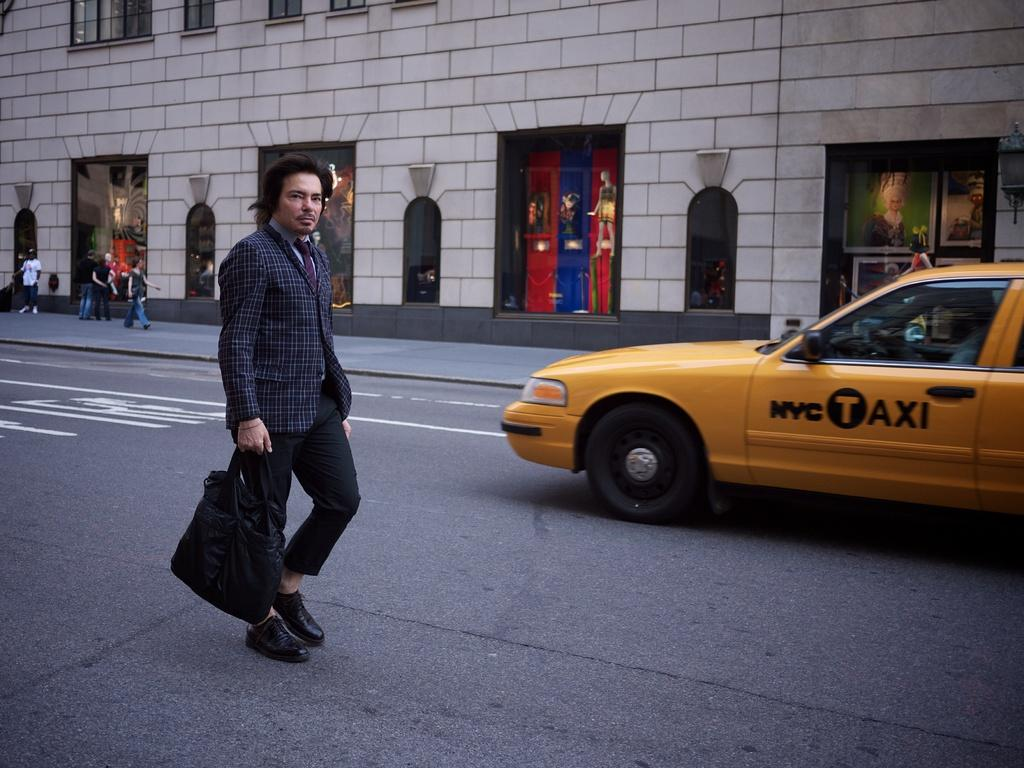<image>
Present a compact description of the photo's key features. A man walking on the street in front of a taxi that reads NYC TAXI. 